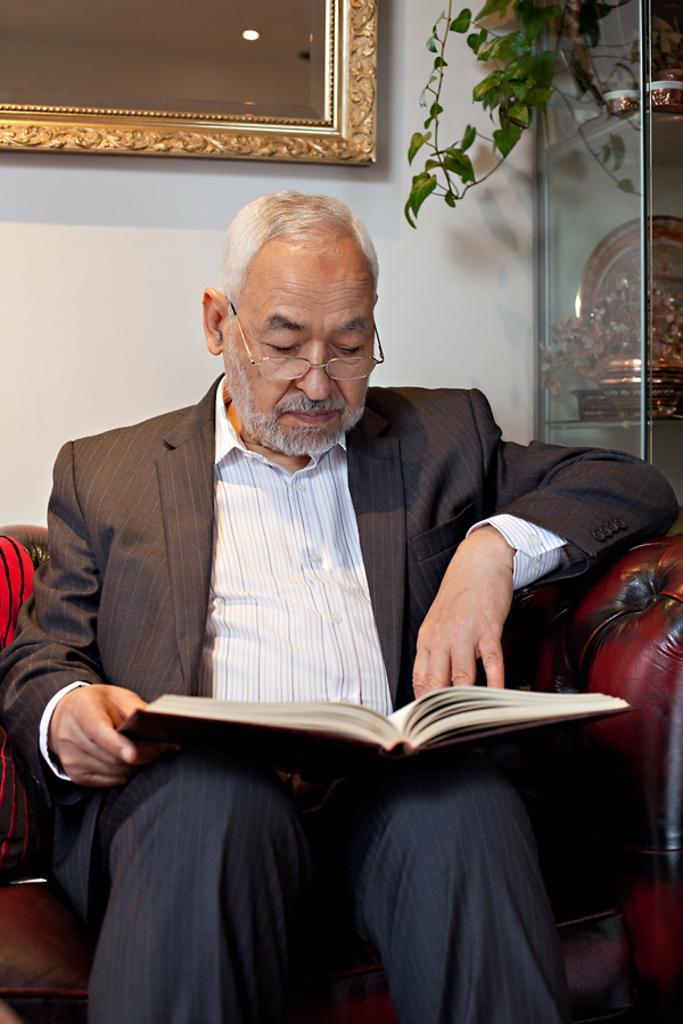In one or two sentences, can you explain what this image depicts? In the picture there is a person sitting on the sofa and reading the book, behind the person there is a wall, on the wall there is a mirror, there is a creep. 